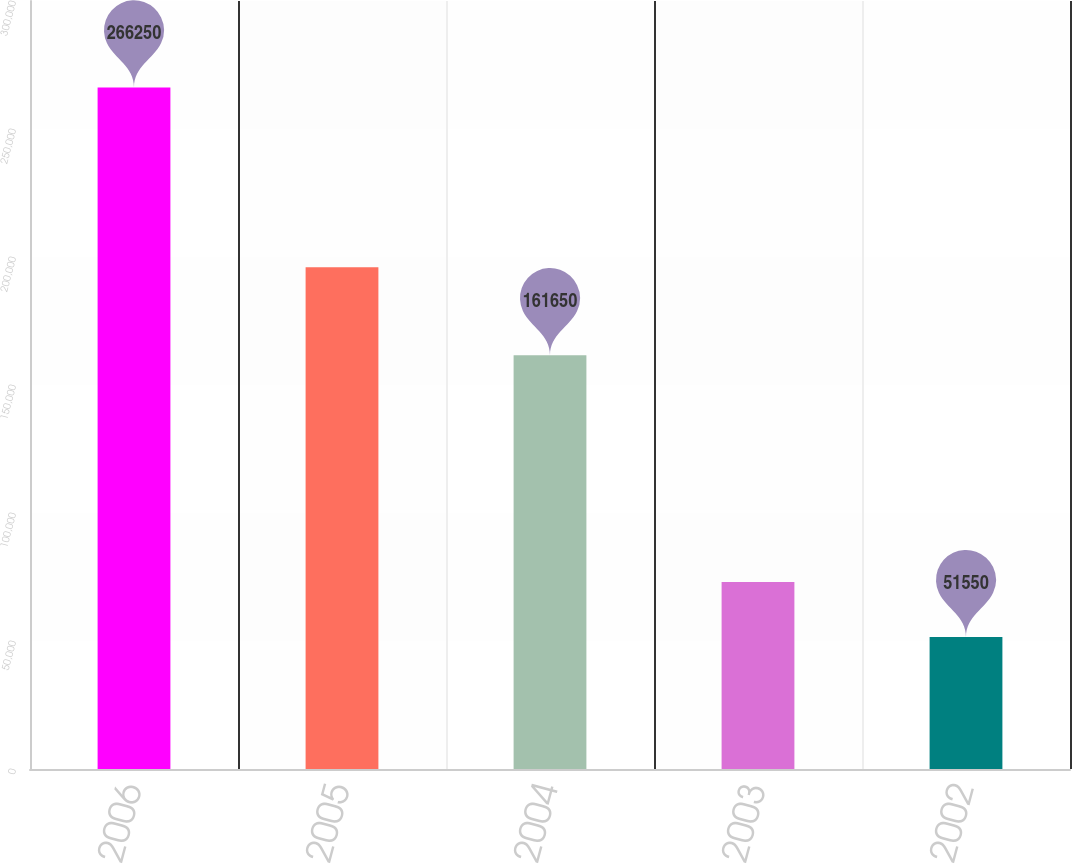Convert chart to OTSL. <chart><loc_0><loc_0><loc_500><loc_500><bar_chart><fcel>2006<fcel>2005<fcel>2004<fcel>2003<fcel>2002<nl><fcel>266250<fcel>195975<fcel>161650<fcel>73020<fcel>51550<nl></chart> 